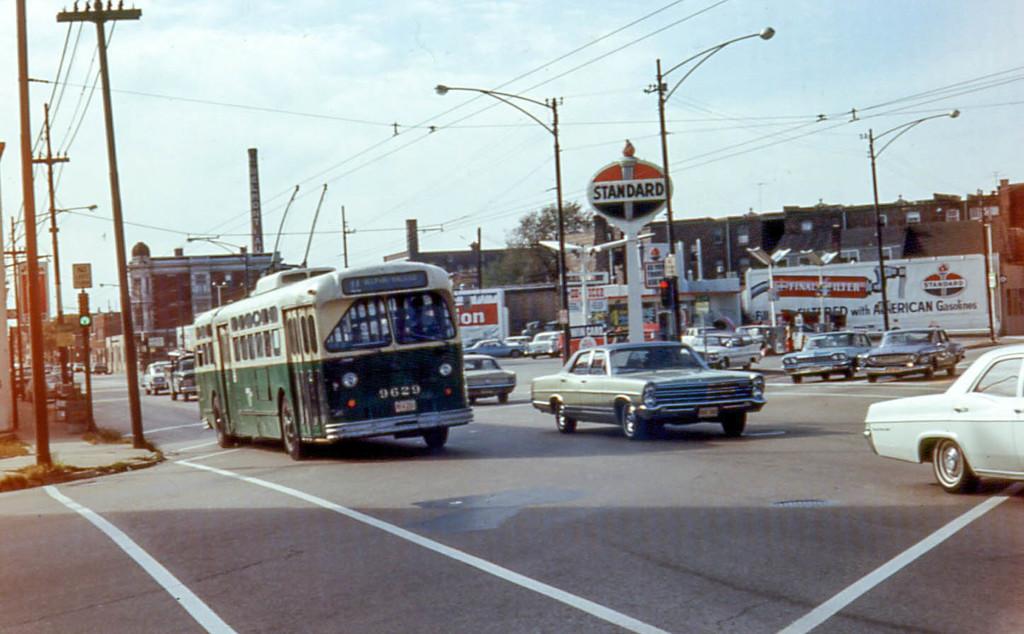What is the bus number?
Your answer should be very brief. 9629. What is the name displayed on the gas station sign?
Provide a succinct answer. Standard. 